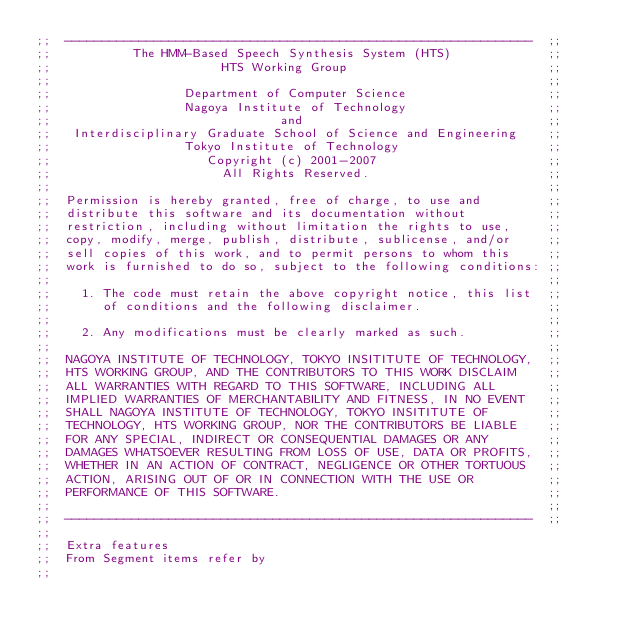<code> <loc_0><loc_0><loc_500><loc_500><_Scheme_>;;  ---------------------------------------------------------------  ;;
;;           The HMM-Based Speech Synthesis System (HTS)             ;;
;;                       HTS Working Group                           ;;
;;                                                                   ;;
;;                  Department of Computer Science                   ;;
;;                  Nagoya Institute of Technology                   ;;
;;                               and                                 ;;
;;   Interdisciplinary Graduate School of Science and Engineering    ;;
;;                  Tokyo Institute of Technology                    ;;
;;                     Copyright (c) 2001-2007                       ;;
;;                       All Rights Reserved.                        ;;
;;                                                                   ;;
;;  Permission is hereby granted, free of charge, to use and         ;;
;;  distribute this software and its documentation without           ;;
;;  restriction, including without limitation the rights to use,     ;;
;;  copy, modify, merge, publish, distribute, sublicense, and/or     ;;
;;  sell copies of this work, and to permit persons to whom this     ;;
;;  work is furnished to do so, subject to the following conditions: ;;
;;                                                                   ;;
;;    1. The code must retain the above copyright notice, this list  ;;
;;       of conditions and the following disclaimer.                 ;;
;;                                                                   ;;
;;    2. Any modifications must be clearly marked as such.           ;;
;;                                                                   ;;
;;  NAGOYA INSTITUTE OF TECHNOLOGY, TOKYO INSITITUTE OF TECHNOLOGY,  ;;
;;  HTS WORKING GROUP, AND THE CONTRIBUTORS TO THIS WORK DISCLAIM    ;;
;;  ALL WARRANTIES WITH REGARD TO THIS SOFTWARE, INCLUDING ALL       ;;
;;  IMPLIED WARRANTIES OF MERCHANTABILITY AND FITNESS, IN NO EVENT   ;;
;;  SHALL NAGOYA INSTITUTE OF TECHNOLOGY, TOKYO INSITITUTE OF        ;;
;;  TECHNOLOGY, HTS WORKING GROUP, NOR THE CONTRIBUTORS BE LIABLE    ;;
;;  FOR ANY SPECIAL, INDIRECT OR CONSEQUENTIAL DAMAGES OR ANY        ;;
;;  DAMAGES WHATSOEVER RESULTING FROM LOSS OF USE, DATA OR PROFITS,  ;;
;;  WHETHER IN AN ACTION OF CONTRACT, NEGLIGENCE OR OTHER TORTUOUS   ;;
;;  ACTION, ARISING OUT OF OR IN CONNECTION WITH THE USE OR          ;;
;;  PERFORMANCE OF THIS SOFTWARE.                                    ;;
;;                                                                   ;;
;;  ---------------------------------------------------------------  ;;
;;
;;  Extra features
;;  From Segment items refer by 
;;</code> 